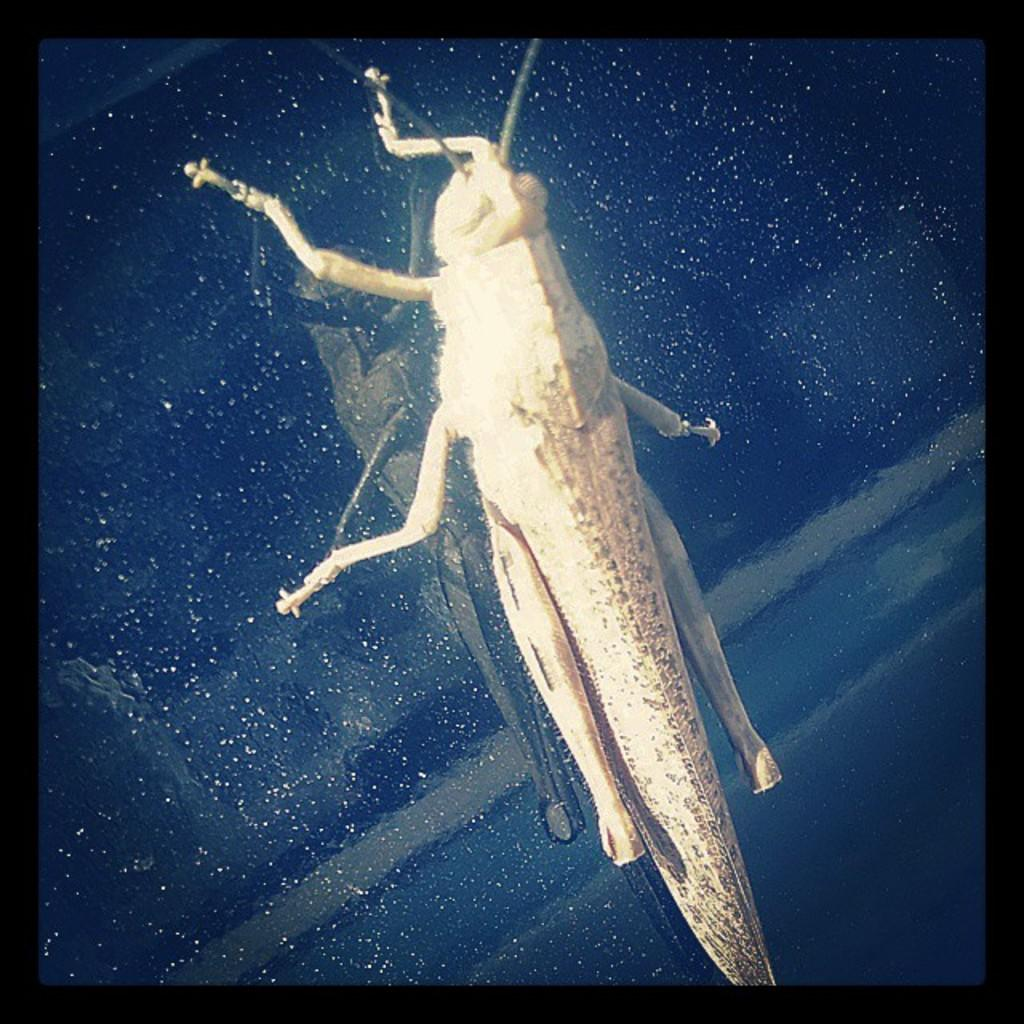What is present on the glass window in the image? There is an insect on the glass window in the image. What type of business is being conducted in the image? There is no indication of any business being conducted in the image; it only features an insect on a glass window. 